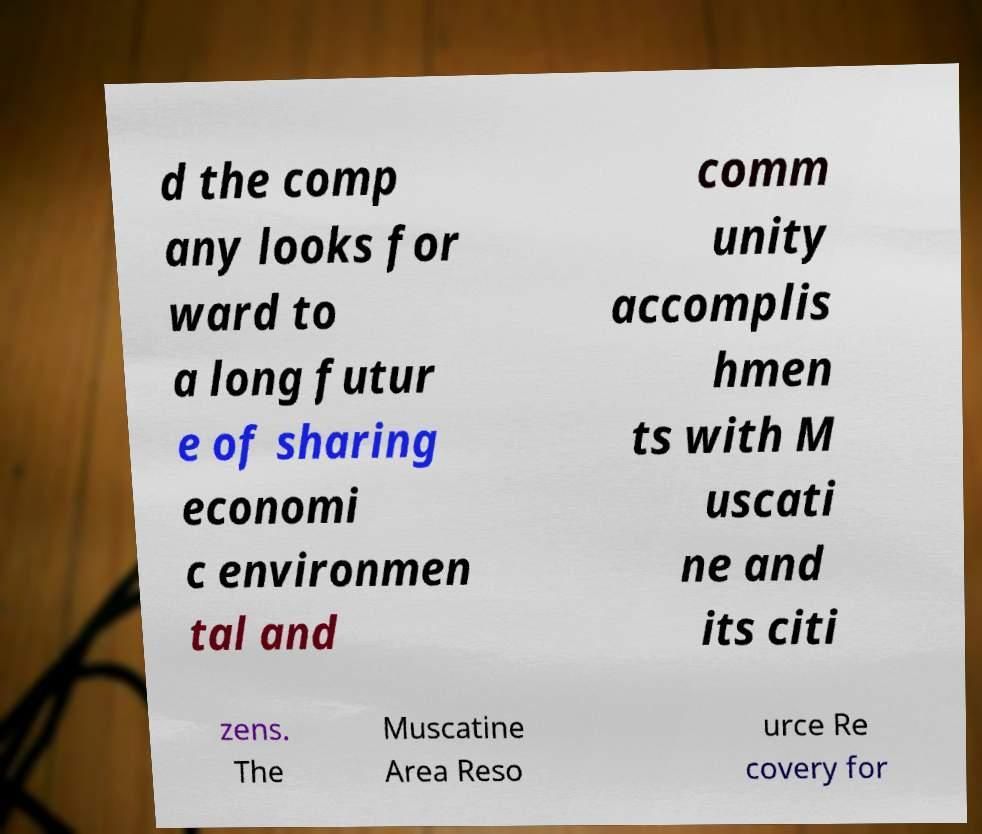Can you read and provide the text displayed in the image?This photo seems to have some interesting text. Can you extract and type it out for me? d the comp any looks for ward to a long futur e of sharing economi c environmen tal and comm unity accomplis hmen ts with M uscati ne and its citi zens. The Muscatine Area Reso urce Re covery for 